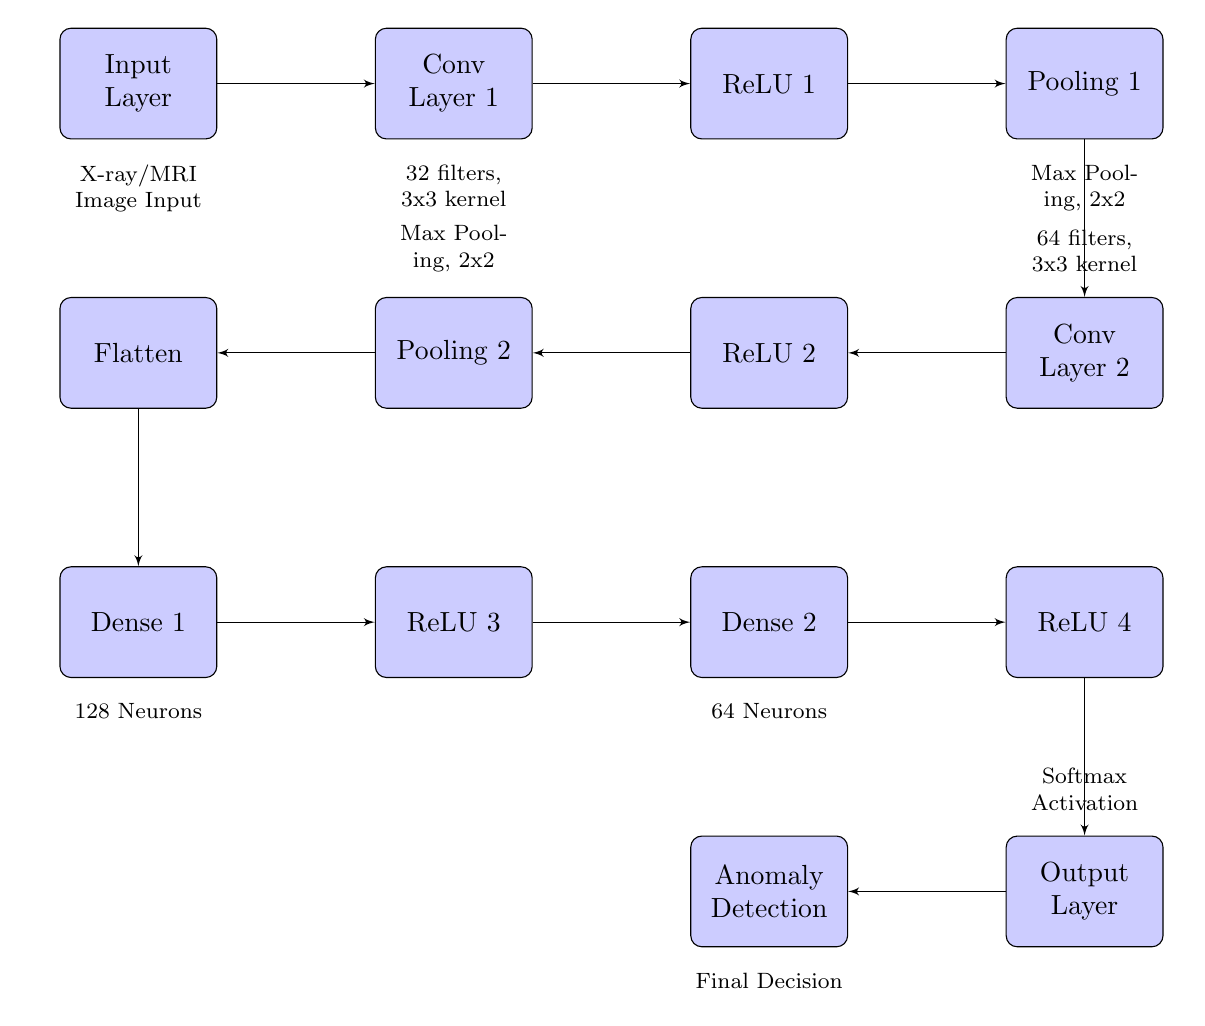What is the number of filters used in Conv Layer 1? In the diagram, Conv Layer 1 is described with "32 filters, 3x3 kernel" below it. This indicates that there are 32 filters used in this layer.
Answer: 32 What type of activation function is applied in Dense Layer 2? According to the diagram, following Dense Layer 2 is "ReLU 4", indicating that the activation function used in Dense Layer 2 is the ReLU (Rectified Linear Unit) function.
Answer: ReLU What is the output of the model? The diagram shows an arrow leading from the Output Layer to the Anomaly Detection block, suggesting that the output is focused on anomaly detection.
Answer: Anomaly Detection How many neurons are in Dense Layer 1? The diagram notes "128 Neurons" below Dense Layer 1, clearly stating that this layer contains 128 neurons.
Answer: 128 What type of pooling is used after Conv Layer 1? In the diagram, Pooling 1 is labeled "Max Pooling, 2x2", indicating that the type of pooling used after Conv Layer 1 is Max Pooling with a 2x2 configuration.
Answer: Max Pooling, 2x2 What is the minimum height of the input layer block? The input layer block description states "minimum height=4em" within the block style definition, indicating that the minimum height for the block is 4em.
Answer: 4em Which layer comes after Pooling Layer 2? From the diagram, the flow moves from Pooling Layer 2 to the Flatten layer, making it the next layer in the sequence.
Answer: Flatten How many dense layers are in the diagram? The diagram shows two dense layers, identified as Dense 1 and Dense 2, thus totaling two dense layers in the architecture.
Answer: 2 What is the purpose of the Softmax activation? The Output Layer is labeled "Softmax Activation," which indicates that the purpose of this activation function is to convert the model's outputs into probabilities for multi-class classification.
Answer: Convert outputs to probabilities 